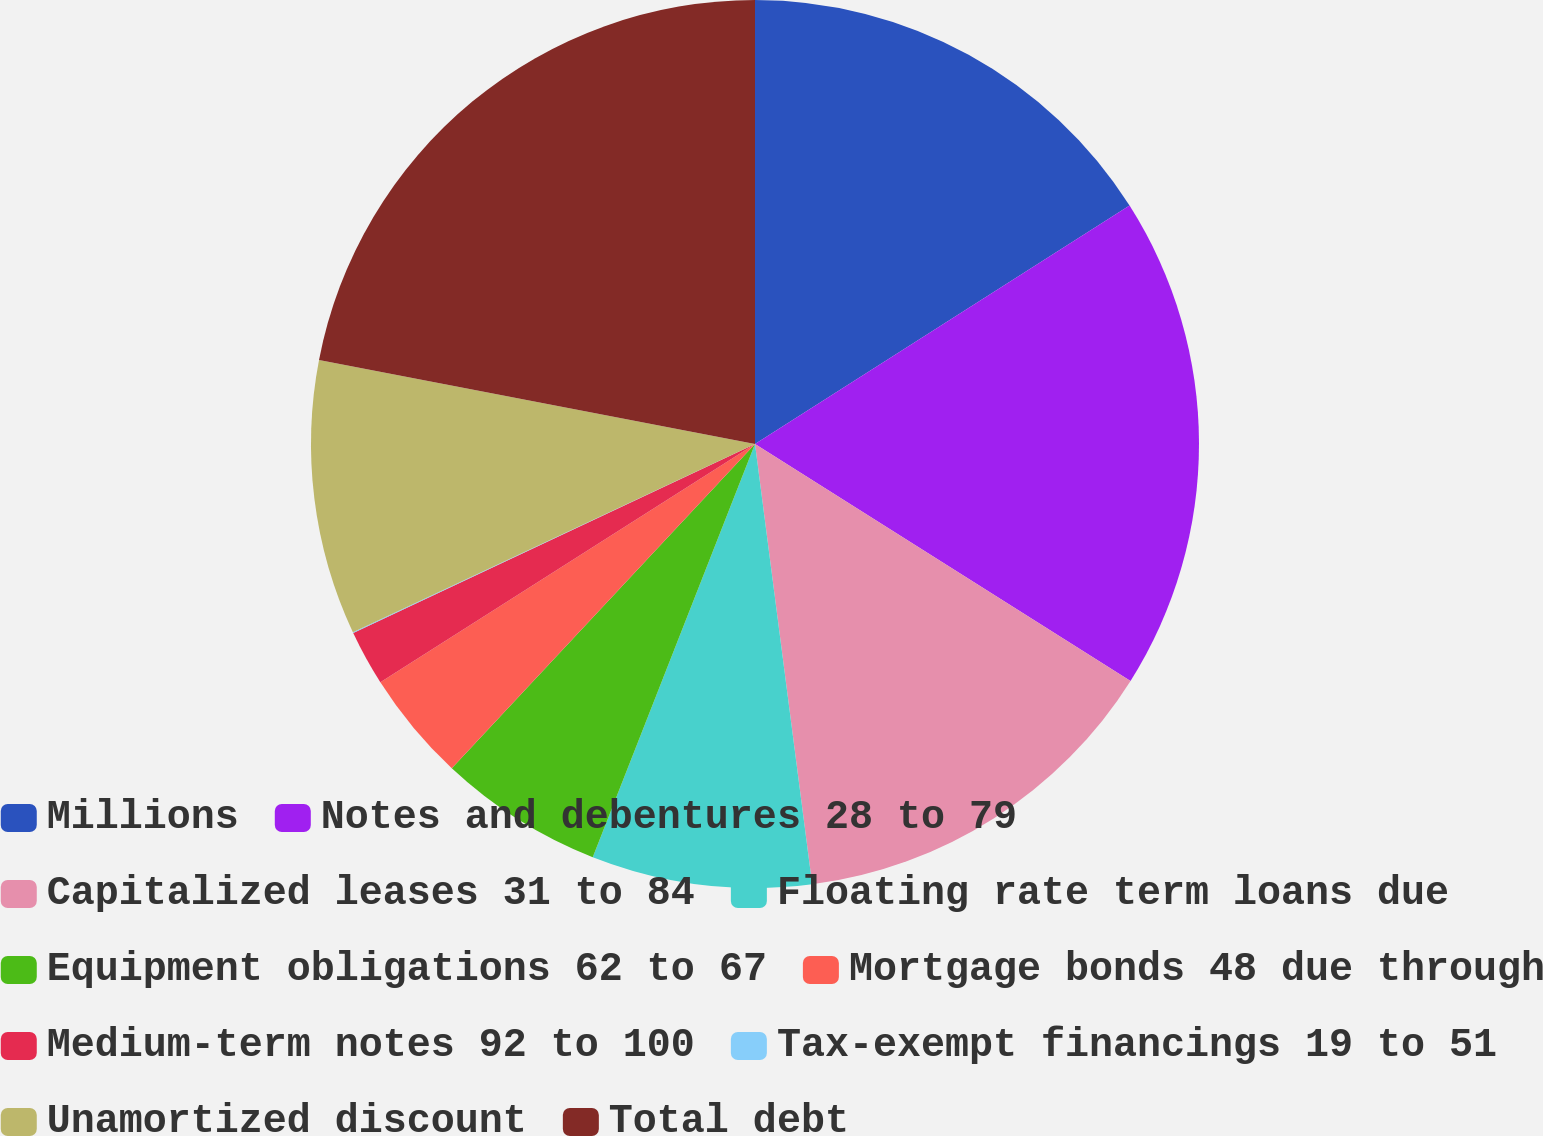<chart> <loc_0><loc_0><loc_500><loc_500><pie_chart><fcel>Millions<fcel>Notes and debentures 28 to 79<fcel>Capitalized leases 31 to 84<fcel>Floating rate term loans due<fcel>Equipment obligations 62 to 67<fcel>Mortgage bonds 48 due through<fcel>Medium-term notes 92 to 100<fcel>Tax-exempt financings 19 to 51<fcel>Unamortized discount<fcel>Total debt<nl><fcel>15.98%<fcel>17.98%<fcel>13.99%<fcel>8.01%<fcel>6.01%<fcel>4.02%<fcel>2.02%<fcel>0.03%<fcel>10.0%<fcel>21.97%<nl></chart> 